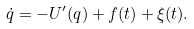Convert formula to latex. <formula><loc_0><loc_0><loc_500><loc_500>\dot { q } = - U ^ { \prime } ( q ) + f ( t ) + \xi ( t ) .</formula> 